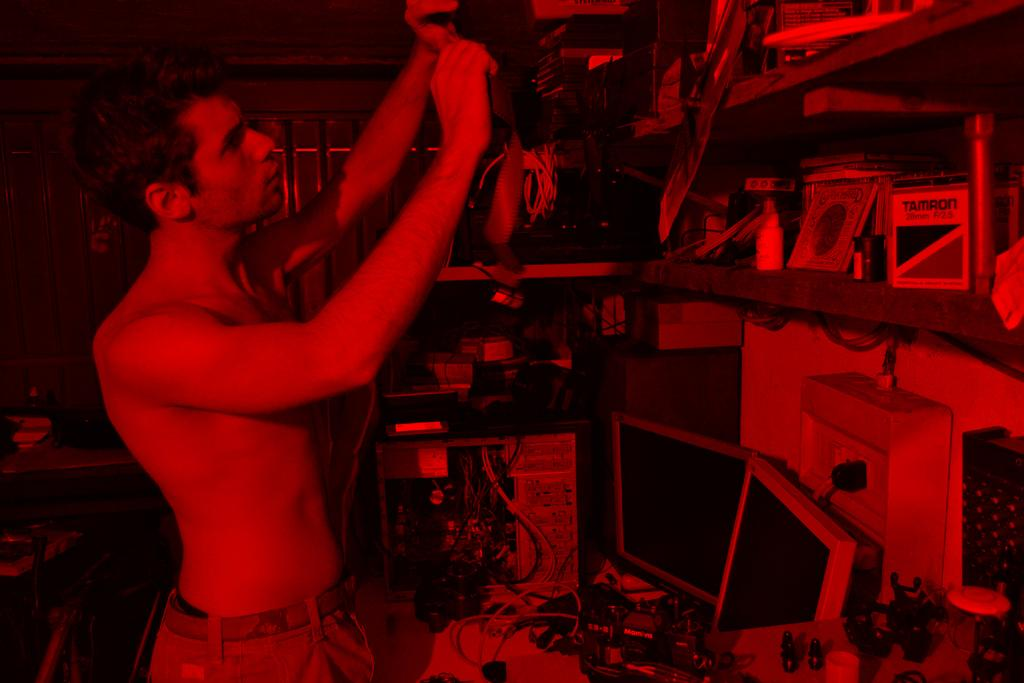What is the primary subject in the image? There is a person standing in the image. Where is the person standing? The person is standing on the floor. What can be seen in the cupboards in the image? Objects are arranged in cupboards. What can be seen on the desktops in the image? Objects are arranged on desktops. What type of electrical device is present in the image? There is a switch board in the image. What is connected to the switch board? Cables are present in the image. What type of straw is the person wearing in the image? There is no straw present in the image; the person is not wearing any clothing or accessory related to a straw. 